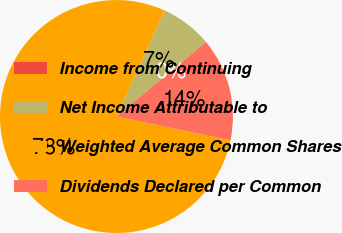Convert chart. <chart><loc_0><loc_0><loc_500><loc_500><pie_chart><fcel>Income from Continuing<fcel>Net Income Attributable to<fcel>Weighted Average Common Shares<fcel>Dividends Declared per Common<nl><fcel>0.0%<fcel>7.17%<fcel>78.5%<fcel>14.33%<nl></chart> 